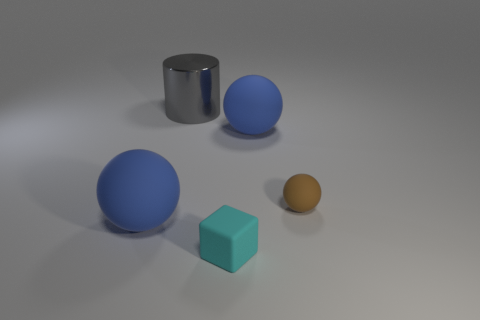There is a tiny cyan cube that is on the left side of the large matte object that is behind the tiny brown rubber thing; how many things are to the right of it? 2 